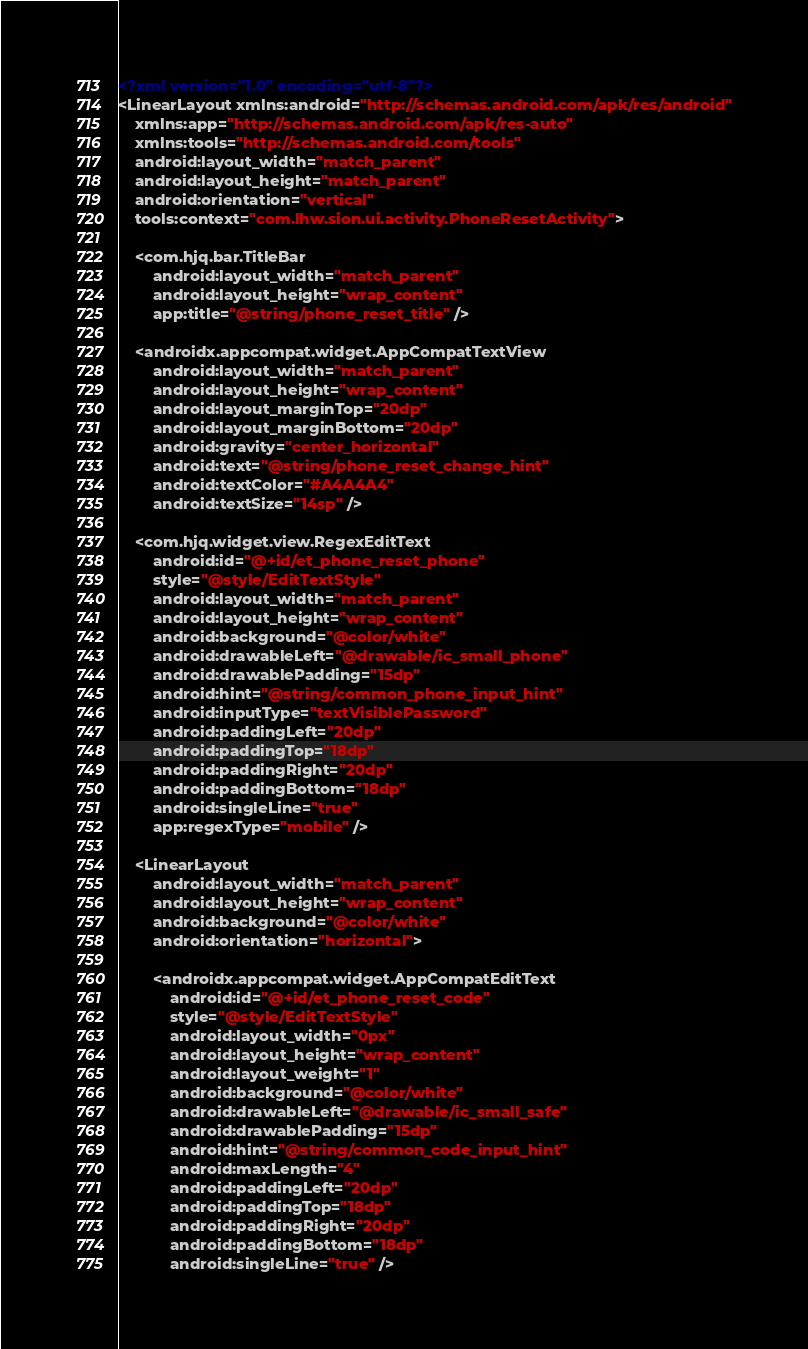Convert code to text. <code><loc_0><loc_0><loc_500><loc_500><_XML_><?xml version="1.0" encoding="utf-8"?>
<LinearLayout xmlns:android="http://schemas.android.com/apk/res/android"
    xmlns:app="http://schemas.android.com/apk/res-auto"
    xmlns:tools="http://schemas.android.com/tools"
    android:layout_width="match_parent"
    android:layout_height="match_parent"
    android:orientation="vertical"
    tools:context="com.lhw.sion.ui.activity.PhoneResetActivity">

    <com.hjq.bar.TitleBar
        android:layout_width="match_parent"
        android:layout_height="wrap_content"
        app:title="@string/phone_reset_title" />

    <androidx.appcompat.widget.AppCompatTextView
        android:layout_width="match_parent"
        android:layout_height="wrap_content"
        android:layout_marginTop="20dp"
        android:layout_marginBottom="20dp"
        android:gravity="center_horizontal"
        android:text="@string/phone_reset_change_hint"
        android:textColor="#A4A4A4"
        android:textSize="14sp" />

    <com.hjq.widget.view.RegexEditText
        android:id="@+id/et_phone_reset_phone"
        style="@style/EditTextStyle"
        android:layout_width="match_parent"
        android:layout_height="wrap_content"
        android:background="@color/white"
        android:drawableLeft="@drawable/ic_small_phone"
        android:drawablePadding="15dp"
        android:hint="@string/common_phone_input_hint"
        android:inputType="textVisiblePassword"
        android:paddingLeft="20dp"
        android:paddingTop="18dp"
        android:paddingRight="20dp"
        android:paddingBottom="18dp"
        android:singleLine="true"
        app:regexType="mobile" />

    <LinearLayout
        android:layout_width="match_parent"
        android:layout_height="wrap_content"
        android:background="@color/white"
        android:orientation="horizontal">

        <androidx.appcompat.widget.AppCompatEditText
            android:id="@+id/et_phone_reset_code"
            style="@style/EditTextStyle"
            android:layout_width="0px"
            android:layout_height="wrap_content"
            android:layout_weight="1"
            android:background="@color/white"
            android:drawableLeft="@drawable/ic_small_safe"
            android:drawablePadding="15dp"
            android:hint="@string/common_code_input_hint"
            android:maxLength="4"
            android:paddingLeft="20dp"
            android:paddingTop="18dp"
            android:paddingRight="20dp"
            android:paddingBottom="18dp"
            android:singleLine="true" />
</code> 